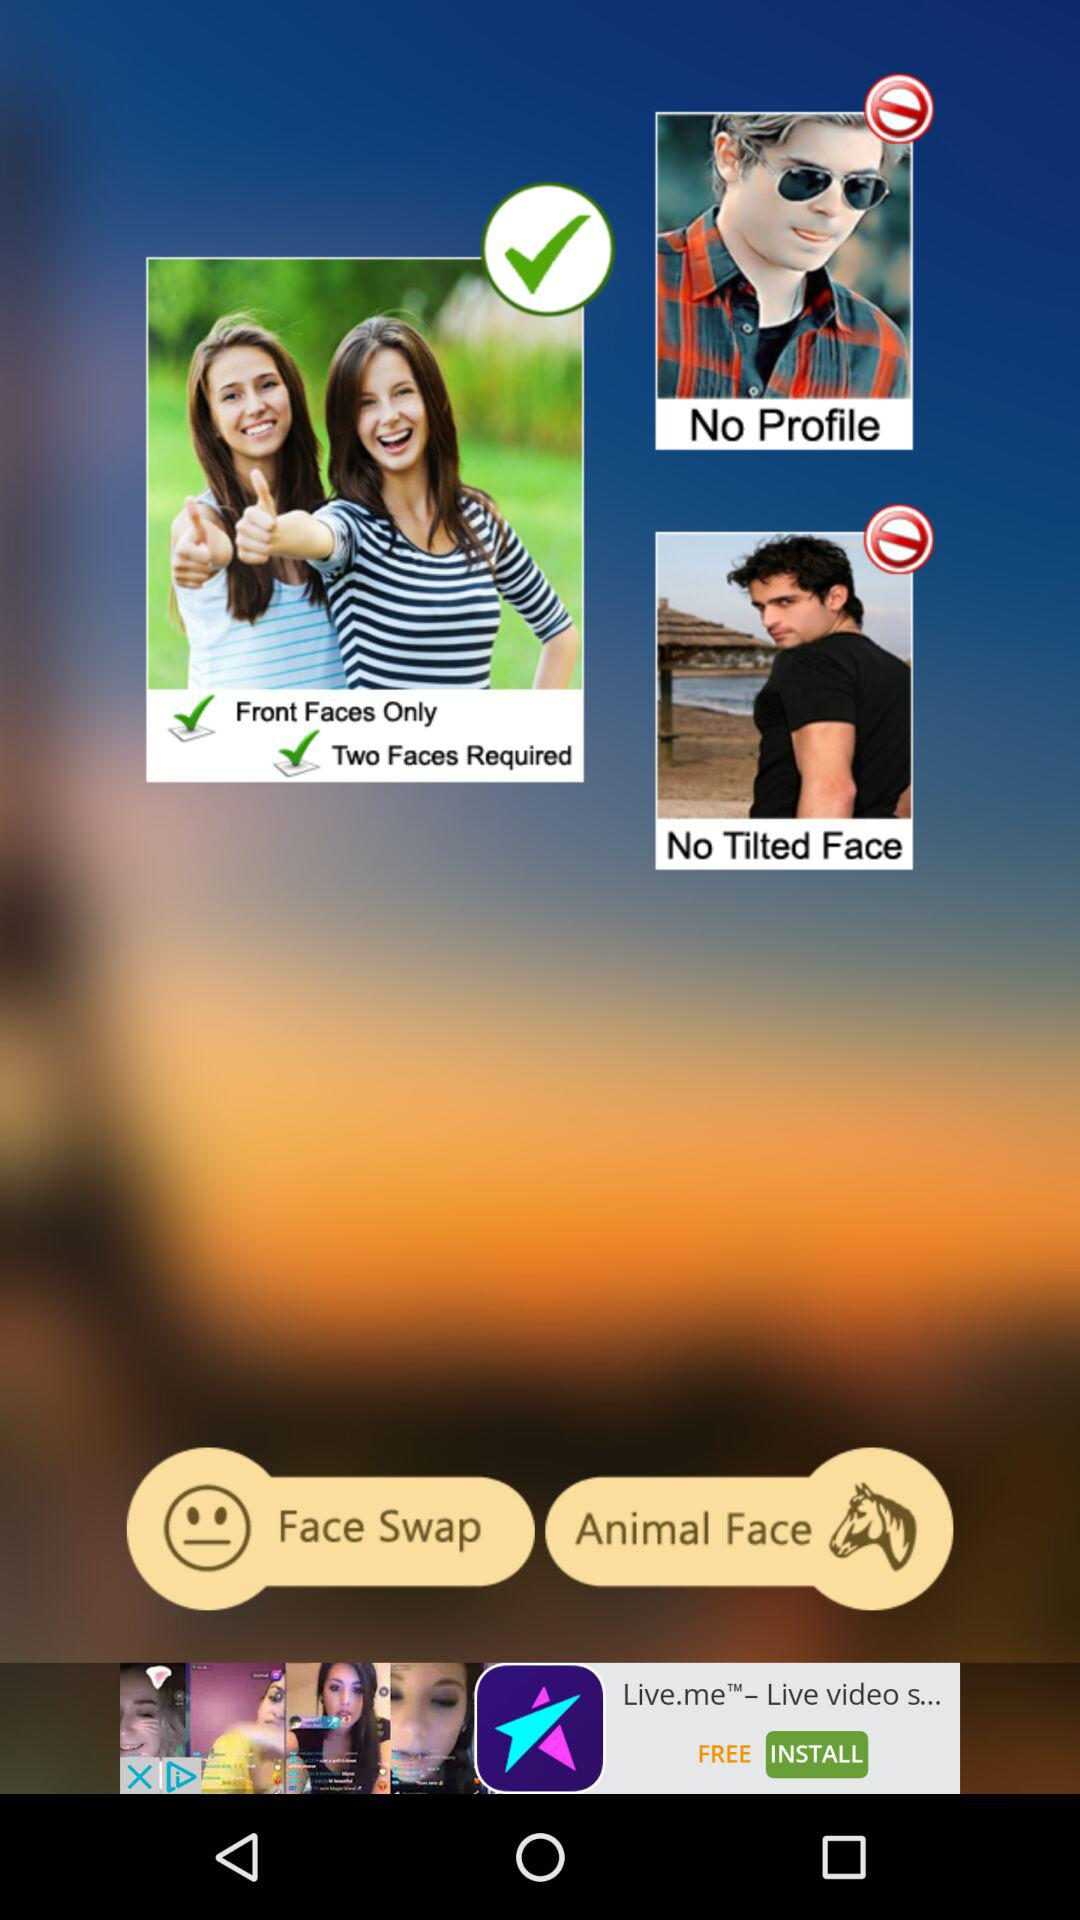How many check marks are there on the screen?
Answer the question using a single word or phrase. 3 